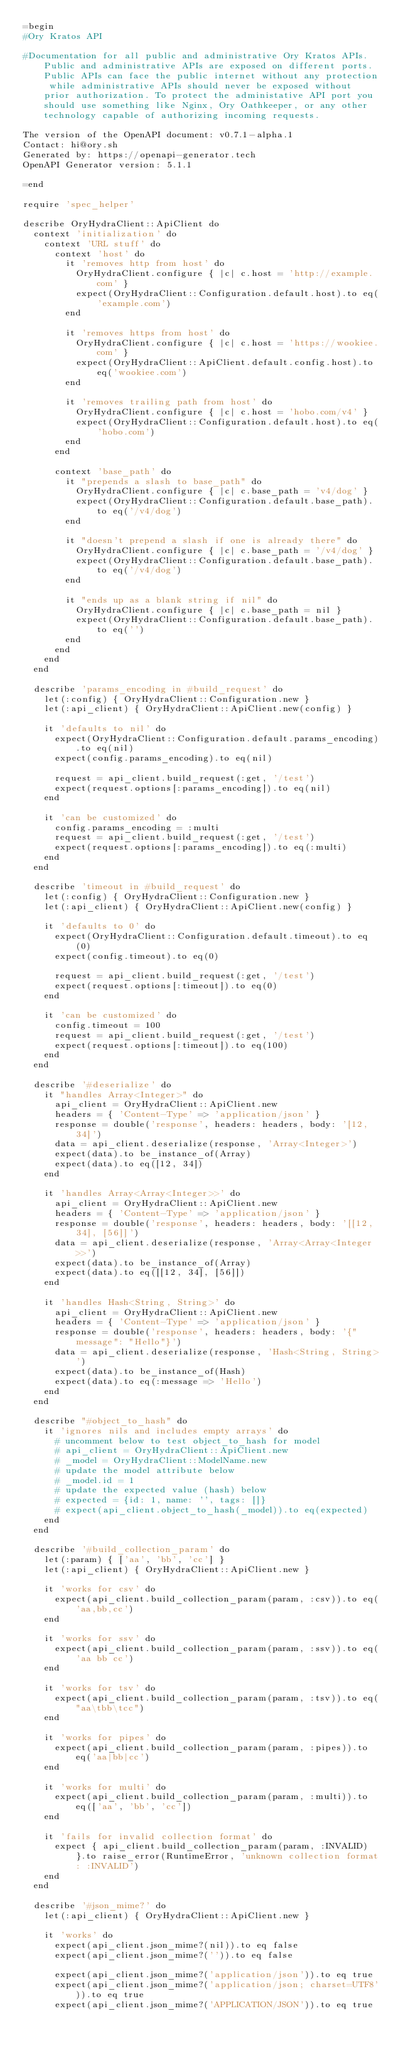<code> <loc_0><loc_0><loc_500><loc_500><_Ruby_>=begin
#Ory Kratos API

#Documentation for all public and administrative Ory Kratos APIs. Public and administrative APIs are exposed on different ports. Public APIs can face the public internet without any protection while administrative APIs should never be exposed without prior authorization. To protect the administative API port you should use something like Nginx, Ory Oathkeeper, or any other technology capable of authorizing incoming requests. 

The version of the OpenAPI document: v0.7.1-alpha.1
Contact: hi@ory.sh
Generated by: https://openapi-generator.tech
OpenAPI Generator version: 5.1.1

=end

require 'spec_helper'

describe OryHydraClient::ApiClient do
  context 'initialization' do
    context 'URL stuff' do
      context 'host' do
        it 'removes http from host' do
          OryHydraClient.configure { |c| c.host = 'http://example.com' }
          expect(OryHydraClient::Configuration.default.host).to eq('example.com')
        end

        it 'removes https from host' do
          OryHydraClient.configure { |c| c.host = 'https://wookiee.com' }
          expect(OryHydraClient::ApiClient.default.config.host).to eq('wookiee.com')
        end

        it 'removes trailing path from host' do
          OryHydraClient.configure { |c| c.host = 'hobo.com/v4' }
          expect(OryHydraClient::Configuration.default.host).to eq('hobo.com')
        end
      end

      context 'base_path' do
        it "prepends a slash to base_path" do
          OryHydraClient.configure { |c| c.base_path = 'v4/dog' }
          expect(OryHydraClient::Configuration.default.base_path).to eq('/v4/dog')
        end

        it "doesn't prepend a slash if one is already there" do
          OryHydraClient.configure { |c| c.base_path = '/v4/dog' }
          expect(OryHydraClient::Configuration.default.base_path).to eq('/v4/dog')
        end

        it "ends up as a blank string if nil" do
          OryHydraClient.configure { |c| c.base_path = nil }
          expect(OryHydraClient::Configuration.default.base_path).to eq('')
        end
      end
    end
  end

  describe 'params_encoding in #build_request' do
    let(:config) { OryHydraClient::Configuration.new }
    let(:api_client) { OryHydraClient::ApiClient.new(config) }

    it 'defaults to nil' do
      expect(OryHydraClient::Configuration.default.params_encoding).to eq(nil)
      expect(config.params_encoding).to eq(nil)

      request = api_client.build_request(:get, '/test')
      expect(request.options[:params_encoding]).to eq(nil)
    end

    it 'can be customized' do
      config.params_encoding = :multi
      request = api_client.build_request(:get, '/test')
      expect(request.options[:params_encoding]).to eq(:multi)
    end
  end

  describe 'timeout in #build_request' do
    let(:config) { OryHydraClient::Configuration.new }
    let(:api_client) { OryHydraClient::ApiClient.new(config) }

    it 'defaults to 0' do
      expect(OryHydraClient::Configuration.default.timeout).to eq(0)
      expect(config.timeout).to eq(0)

      request = api_client.build_request(:get, '/test')
      expect(request.options[:timeout]).to eq(0)
    end

    it 'can be customized' do
      config.timeout = 100
      request = api_client.build_request(:get, '/test')
      expect(request.options[:timeout]).to eq(100)
    end
  end

  describe '#deserialize' do
    it "handles Array<Integer>" do
      api_client = OryHydraClient::ApiClient.new
      headers = { 'Content-Type' => 'application/json' }
      response = double('response', headers: headers, body: '[12, 34]')
      data = api_client.deserialize(response, 'Array<Integer>')
      expect(data).to be_instance_of(Array)
      expect(data).to eq([12, 34])
    end

    it 'handles Array<Array<Integer>>' do
      api_client = OryHydraClient::ApiClient.new
      headers = { 'Content-Type' => 'application/json' }
      response = double('response', headers: headers, body: '[[12, 34], [56]]')
      data = api_client.deserialize(response, 'Array<Array<Integer>>')
      expect(data).to be_instance_of(Array)
      expect(data).to eq([[12, 34], [56]])
    end

    it 'handles Hash<String, String>' do
      api_client = OryHydraClient::ApiClient.new
      headers = { 'Content-Type' => 'application/json' }
      response = double('response', headers: headers, body: '{"message": "Hello"}')
      data = api_client.deserialize(response, 'Hash<String, String>')
      expect(data).to be_instance_of(Hash)
      expect(data).to eq(:message => 'Hello')
    end
  end

  describe "#object_to_hash" do
    it 'ignores nils and includes empty arrays' do
      # uncomment below to test object_to_hash for model
      # api_client = OryHydraClient::ApiClient.new
      # _model = OryHydraClient::ModelName.new
      # update the model attribute below
      # _model.id = 1
      # update the expected value (hash) below
      # expected = {id: 1, name: '', tags: []}
      # expect(api_client.object_to_hash(_model)).to eq(expected)
    end
  end

  describe '#build_collection_param' do
    let(:param) { ['aa', 'bb', 'cc'] }
    let(:api_client) { OryHydraClient::ApiClient.new }

    it 'works for csv' do
      expect(api_client.build_collection_param(param, :csv)).to eq('aa,bb,cc')
    end

    it 'works for ssv' do
      expect(api_client.build_collection_param(param, :ssv)).to eq('aa bb cc')
    end

    it 'works for tsv' do
      expect(api_client.build_collection_param(param, :tsv)).to eq("aa\tbb\tcc")
    end

    it 'works for pipes' do
      expect(api_client.build_collection_param(param, :pipes)).to eq('aa|bb|cc')
    end

    it 'works for multi' do
      expect(api_client.build_collection_param(param, :multi)).to eq(['aa', 'bb', 'cc'])
    end

    it 'fails for invalid collection format' do
      expect { api_client.build_collection_param(param, :INVALID) }.to raise_error(RuntimeError, 'unknown collection format: :INVALID')
    end
  end

  describe '#json_mime?' do
    let(:api_client) { OryHydraClient::ApiClient.new }

    it 'works' do
      expect(api_client.json_mime?(nil)).to eq false
      expect(api_client.json_mime?('')).to eq false

      expect(api_client.json_mime?('application/json')).to eq true
      expect(api_client.json_mime?('application/json; charset=UTF8')).to eq true
      expect(api_client.json_mime?('APPLICATION/JSON')).to eq true
</code> 